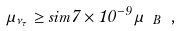Convert formula to latex. <formula><loc_0><loc_0><loc_500><loc_500>\mu _ { \nu _ { \tau } } \geq s i m 7 \times 1 0 ^ { - 9 } \mu _ { \ B } \ ,</formula> 